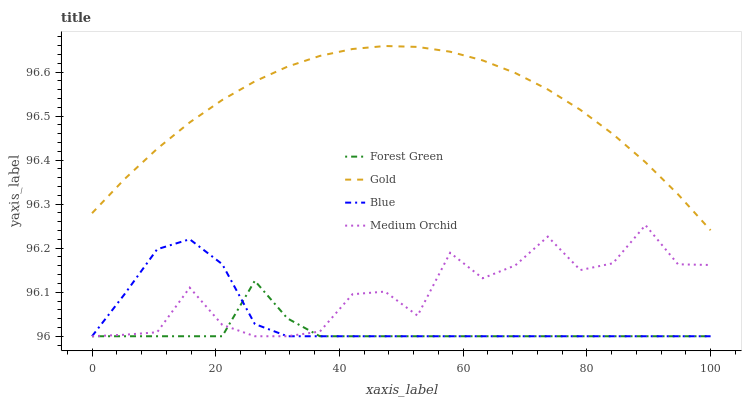Does Forest Green have the minimum area under the curve?
Answer yes or no. Yes. Does Gold have the maximum area under the curve?
Answer yes or no. Yes. Does Medium Orchid have the minimum area under the curve?
Answer yes or no. No. Does Medium Orchid have the maximum area under the curve?
Answer yes or no. No. Is Gold the smoothest?
Answer yes or no. Yes. Is Medium Orchid the roughest?
Answer yes or no. Yes. Is Forest Green the smoothest?
Answer yes or no. No. Is Forest Green the roughest?
Answer yes or no. No. Does Gold have the lowest value?
Answer yes or no. No. Does Gold have the highest value?
Answer yes or no. Yes. Does Medium Orchid have the highest value?
Answer yes or no. No. Is Medium Orchid less than Gold?
Answer yes or no. Yes. Is Gold greater than Blue?
Answer yes or no. Yes. Does Blue intersect Forest Green?
Answer yes or no. Yes. Is Blue less than Forest Green?
Answer yes or no. No. Is Blue greater than Forest Green?
Answer yes or no. No. Does Medium Orchid intersect Gold?
Answer yes or no. No. 